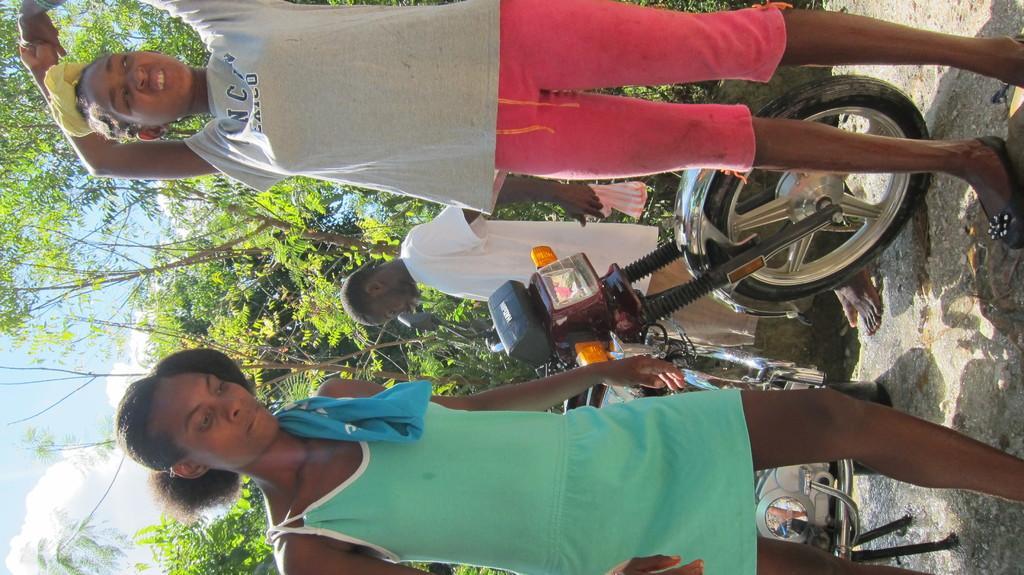In one or two sentences, can you explain what this image depicts? There is a woman in green color dressing, keeping a blue color cloth on her shoulder and standing on the ground, near a girl who is in gray color t-shirt, standing. Beside them, there is a bike parked, near a person who is in white color t-shirt. In the background, there is a wet land, there are trees and there are clouds in the blue sky. 